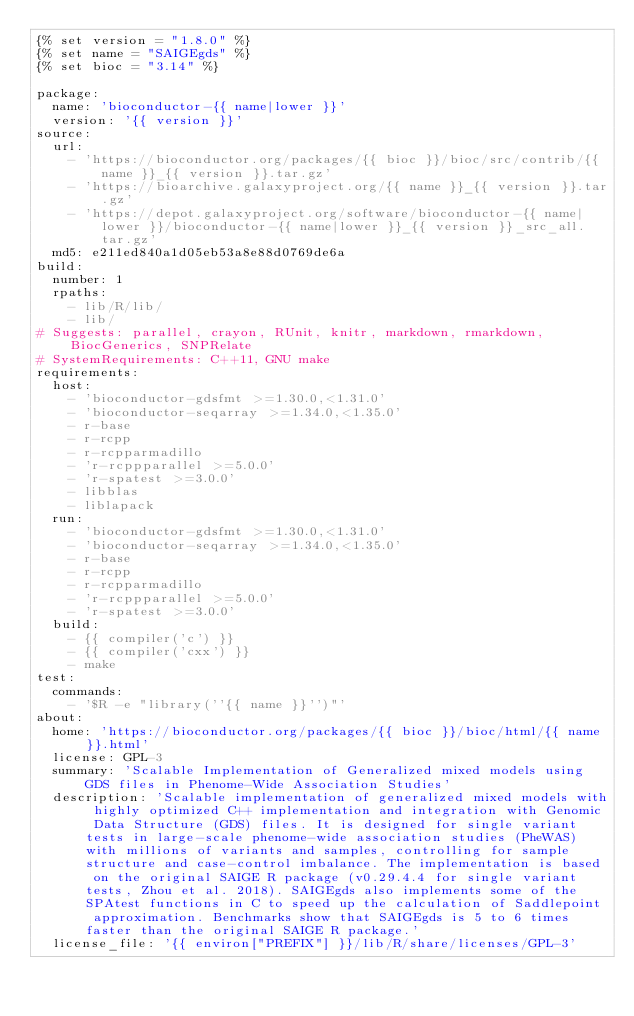<code> <loc_0><loc_0><loc_500><loc_500><_YAML_>{% set version = "1.8.0" %}
{% set name = "SAIGEgds" %}
{% set bioc = "3.14" %}

package:
  name: 'bioconductor-{{ name|lower }}'
  version: '{{ version }}'
source:
  url:
    - 'https://bioconductor.org/packages/{{ bioc }}/bioc/src/contrib/{{ name }}_{{ version }}.tar.gz'
    - 'https://bioarchive.galaxyproject.org/{{ name }}_{{ version }}.tar.gz'
    - 'https://depot.galaxyproject.org/software/bioconductor-{{ name|lower }}/bioconductor-{{ name|lower }}_{{ version }}_src_all.tar.gz'
  md5: e211ed840a1d05eb53a8e88d0769de6a
build:
  number: 1
  rpaths:
    - lib/R/lib/
    - lib/
# Suggests: parallel, crayon, RUnit, knitr, markdown, rmarkdown, BiocGenerics, SNPRelate
# SystemRequirements: C++11, GNU make
requirements:
  host:
    - 'bioconductor-gdsfmt >=1.30.0,<1.31.0'
    - 'bioconductor-seqarray >=1.34.0,<1.35.0'
    - r-base
    - r-rcpp
    - r-rcpparmadillo
    - 'r-rcppparallel >=5.0.0'
    - 'r-spatest >=3.0.0'
    - libblas
    - liblapack
  run:
    - 'bioconductor-gdsfmt >=1.30.0,<1.31.0'
    - 'bioconductor-seqarray >=1.34.0,<1.35.0'
    - r-base
    - r-rcpp
    - r-rcpparmadillo
    - 'r-rcppparallel >=5.0.0'
    - 'r-spatest >=3.0.0'
  build:
    - {{ compiler('c') }}
    - {{ compiler('cxx') }}
    - make
test:
  commands:
    - '$R -e "library(''{{ name }}'')"'
about:
  home: 'https://bioconductor.org/packages/{{ bioc }}/bioc/html/{{ name }}.html'
  license: GPL-3
  summary: 'Scalable Implementation of Generalized mixed models using GDS files in Phenome-Wide Association Studies'
  description: 'Scalable implementation of generalized mixed models with highly optimized C++ implementation and integration with Genomic Data Structure (GDS) files. It is designed for single variant tests in large-scale phenome-wide association studies (PheWAS) with millions of variants and samples, controlling for sample structure and case-control imbalance. The implementation is based on the original SAIGE R package (v0.29.4.4 for single variant tests, Zhou et al. 2018). SAIGEgds also implements some of the SPAtest functions in C to speed up the calculation of Saddlepoint approximation. Benchmarks show that SAIGEgds is 5 to 6 times faster than the original SAIGE R package.'
  license_file: '{{ environ["PREFIX"] }}/lib/R/share/licenses/GPL-3'

</code> 